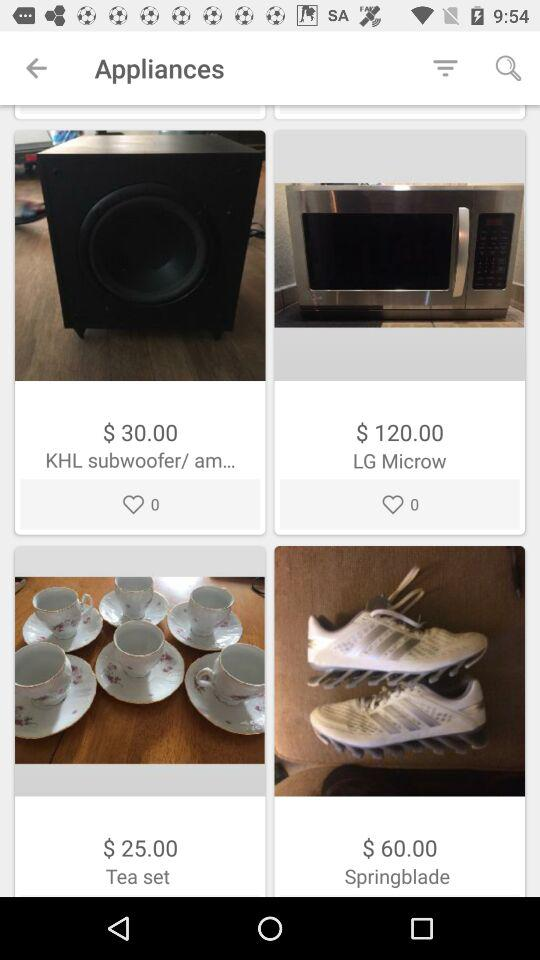How many items have a price less than $50.00?
Answer the question using a single word or phrase. 2 